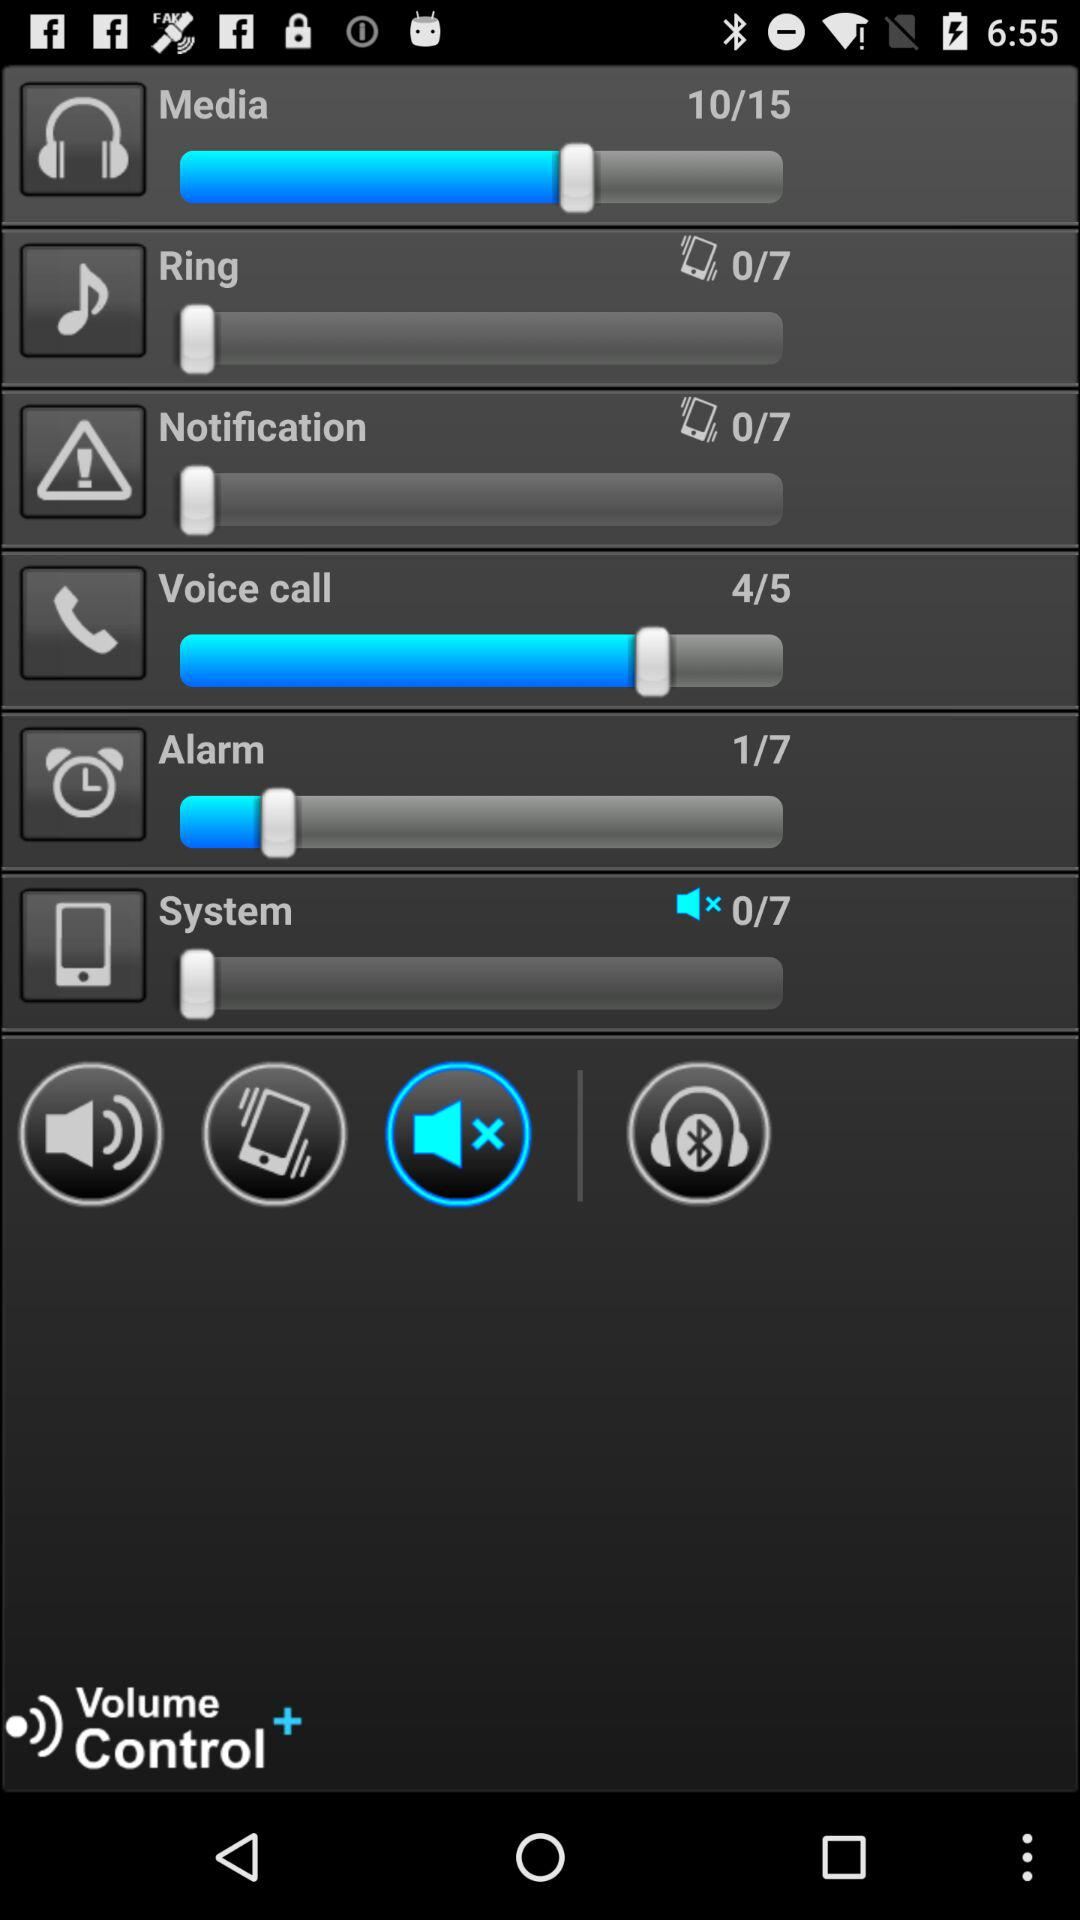What is the total number of voice calls? The total number of voice calls is 5. 